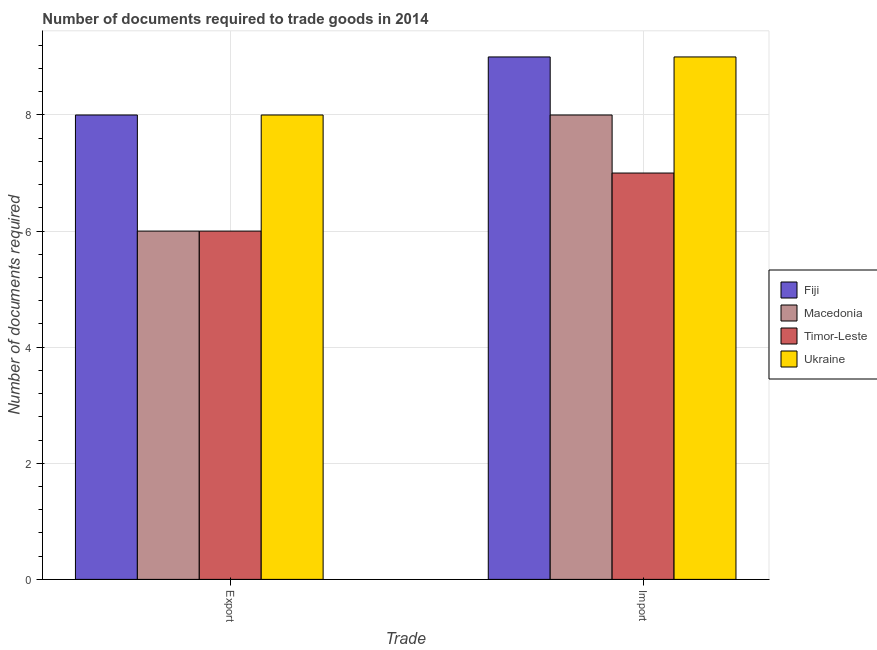How many different coloured bars are there?
Keep it short and to the point. 4. How many groups of bars are there?
Your response must be concise. 2. Are the number of bars per tick equal to the number of legend labels?
Offer a very short reply. Yes. Are the number of bars on each tick of the X-axis equal?
Offer a terse response. Yes. How many bars are there on the 1st tick from the left?
Provide a succinct answer. 4. What is the label of the 2nd group of bars from the left?
Provide a succinct answer. Import. What is the number of documents required to export goods in Timor-Leste?
Ensure brevity in your answer.  6. Across all countries, what is the maximum number of documents required to import goods?
Make the answer very short. 9. Across all countries, what is the minimum number of documents required to import goods?
Your response must be concise. 7. In which country was the number of documents required to export goods maximum?
Provide a succinct answer. Fiji. In which country was the number of documents required to import goods minimum?
Give a very brief answer. Timor-Leste. What is the total number of documents required to import goods in the graph?
Your answer should be compact. 33. What is the difference between the number of documents required to import goods in Macedonia and that in Ukraine?
Make the answer very short. -1. What is the difference between the number of documents required to import goods in Ukraine and the number of documents required to export goods in Timor-Leste?
Offer a very short reply. 3. What is the average number of documents required to export goods per country?
Offer a very short reply. 7. What is the difference between the number of documents required to export goods and number of documents required to import goods in Ukraine?
Your answer should be compact. -1. What is the ratio of the number of documents required to export goods in Ukraine to that in Timor-Leste?
Give a very brief answer. 1.33. Is the number of documents required to export goods in Fiji less than that in Macedonia?
Give a very brief answer. No. In how many countries, is the number of documents required to export goods greater than the average number of documents required to export goods taken over all countries?
Keep it short and to the point. 2. What does the 2nd bar from the left in Import represents?
Make the answer very short. Macedonia. What does the 3rd bar from the right in Export represents?
Make the answer very short. Macedonia. How many bars are there?
Ensure brevity in your answer.  8. What is the difference between two consecutive major ticks on the Y-axis?
Ensure brevity in your answer.  2. Does the graph contain any zero values?
Keep it short and to the point. No. Does the graph contain grids?
Ensure brevity in your answer.  Yes. Where does the legend appear in the graph?
Make the answer very short. Center right. How many legend labels are there?
Provide a succinct answer. 4. What is the title of the graph?
Keep it short and to the point. Number of documents required to trade goods in 2014. What is the label or title of the X-axis?
Your answer should be compact. Trade. What is the label or title of the Y-axis?
Keep it short and to the point. Number of documents required. What is the Number of documents required in Timor-Leste in Export?
Make the answer very short. 6. What is the Number of documents required in Fiji in Import?
Ensure brevity in your answer.  9. What is the Number of documents required in Macedonia in Import?
Provide a succinct answer. 8. What is the Number of documents required in Ukraine in Import?
Give a very brief answer. 9. Across all Trade, what is the maximum Number of documents required in Fiji?
Ensure brevity in your answer.  9. Across all Trade, what is the minimum Number of documents required of Macedonia?
Give a very brief answer. 6. Across all Trade, what is the minimum Number of documents required of Ukraine?
Your answer should be compact. 8. What is the total Number of documents required of Ukraine in the graph?
Offer a terse response. 17. What is the difference between the Number of documents required of Macedonia in Export and that in Import?
Ensure brevity in your answer.  -2. What is the difference between the Number of documents required of Timor-Leste in Export and that in Import?
Provide a succinct answer. -1. What is the difference between the Number of documents required in Fiji in Export and the Number of documents required in Macedonia in Import?
Provide a succinct answer. 0. What is the difference between the Number of documents required in Fiji in Export and the Number of documents required in Timor-Leste in Import?
Keep it short and to the point. 1. What is the difference between the Number of documents required of Macedonia in Export and the Number of documents required of Timor-Leste in Import?
Keep it short and to the point. -1. What is the average Number of documents required in Macedonia per Trade?
Your response must be concise. 7. What is the difference between the Number of documents required of Fiji and Number of documents required of Macedonia in Export?
Your response must be concise. 2. What is the difference between the Number of documents required of Fiji and Number of documents required of Timor-Leste in Export?
Your response must be concise. 2. What is the difference between the Number of documents required of Fiji and Number of documents required of Ukraine in Export?
Your response must be concise. 0. What is the difference between the Number of documents required in Macedonia and Number of documents required in Ukraine in Export?
Keep it short and to the point. -2. What is the difference between the Number of documents required in Timor-Leste and Number of documents required in Ukraine in Export?
Keep it short and to the point. -2. What is the difference between the Number of documents required of Macedonia and Number of documents required of Timor-Leste in Import?
Your response must be concise. 1. What is the difference between the Number of documents required in Macedonia and Number of documents required in Ukraine in Import?
Give a very brief answer. -1. What is the difference between the Number of documents required of Timor-Leste and Number of documents required of Ukraine in Import?
Ensure brevity in your answer.  -2. What is the ratio of the Number of documents required of Fiji in Export to that in Import?
Provide a short and direct response. 0.89. What is the ratio of the Number of documents required of Timor-Leste in Export to that in Import?
Your answer should be very brief. 0.86. What is the difference between the highest and the second highest Number of documents required of Fiji?
Your response must be concise. 1. What is the difference between the highest and the lowest Number of documents required of Fiji?
Keep it short and to the point. 1. 